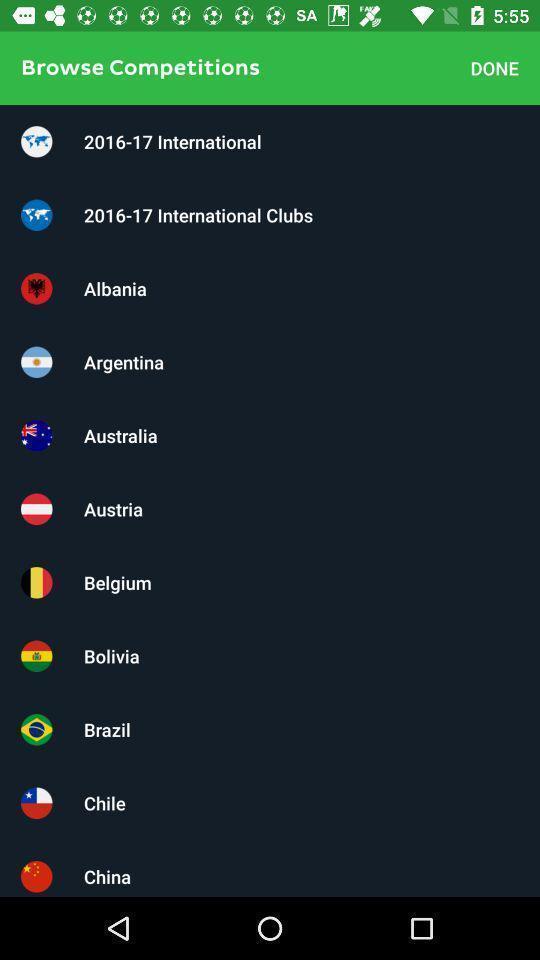Tell me what you see in this picture. Screen displaying the list of countries. 